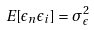<formula> <loc_0><loc_0><loc_500><loc_500>E [ \epsilon _ { n } \epsilon _ { i } ] = \sigma _ { \epsilon } ^ { 2 }</formula> 